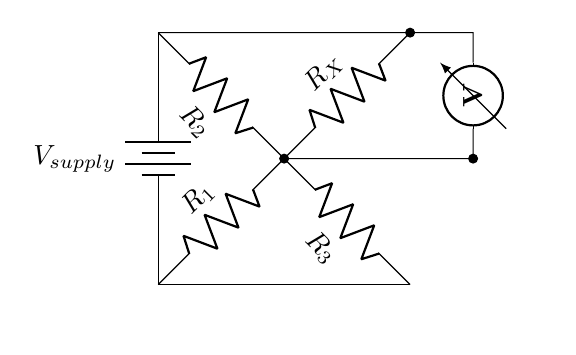What is the purpose of the Wheatstone bridge in this circuit? The Wheatstone bridge is used for measuring unknown resistances, which in this case corresponds to weighing measurements in shipping and logistics.
Answer: Weighing measurement What is the supply voltage denoted in the circuit? The supply voltage is labeled as V_supply in the diagram, usually indicating the input voltage for the circuit.
Answer: V_supply Which component is indicative of the unknown resistance? The unknown resistance is represented by R_X in the circuit diagram, which is compared against the other known resistances in the bridge setup.
Answer: R_X How many resistors are present in the Wheatstone bridge? There are four resistors in total, namely R_1, R_2, R_3, and R_X.
Answer: Four What do the measurement connections to the voltmeter signify in this circuit? The connections to the voltmeter indicate that voltage is being measured across a point in the circuit, which helps to determine the balance of the bridge.
Answer: Voltage measurement What is the role of the resistors R_1 and R_2? Resistors R_1 and R_2 are known resistances that, when balanced with R_X, allow for accurate weighing and measurement in the circuit.
Answer: Known resistances 